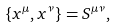<formula> <loc_0><loc_0><loc_500><loc_500>\{ x ^ { \mu } , x ^ { \nu } \} = S ^ { \mu \nu } ,</formula> 